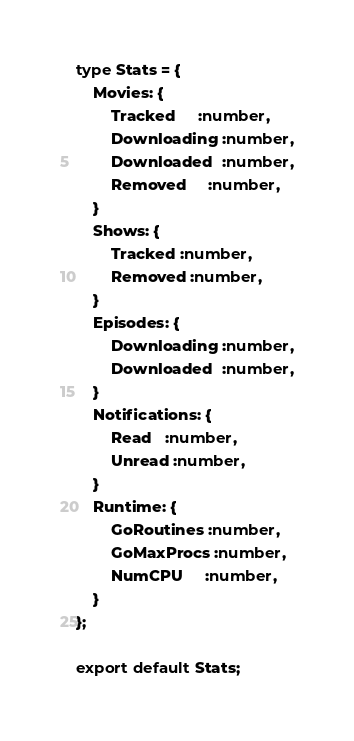Convert code to text. <code><loc_0><loc_0><loc_500><loc_500><_TypeScript_>type Stats = {
	Movies: {
		Tracked     :number,
		Downloading :number,
		Downloaded  :number,
		Removed     :number,
	}
	Shows: {
		Tracked :number,
		Removed :number,
	}
	Episodes: {
		Downloading :number,
		Downloaded  :number,
	}
	Notifications: {
		Read   :number,
		Unread :number,
	}
	Runtime: {
		GoRoutines :number,
		GoMaxProcs :number,
		NumCPU     :number,
	}
};

export default Stats;
</code> 